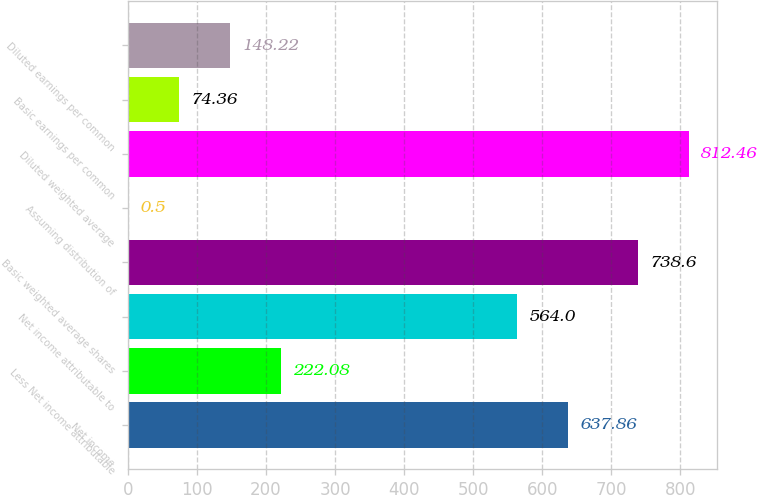Convert chart. <chart><loc_0><loc_0><loc_500><loc_500><bar_chart><fcel>Net income<fcel>Less Net income attributable<fcel>Net income attributable to<fcel>Basic weighted average shares<fcel>Assuming distribution of<fcel>Diluted weighted average<fcel>Basic earnings per common<fcel>Diluted earnings per common<nl><fcel>637.86<fcel>222.08<fcel>564<fcel>738.6<fcel>0.5<fcel>812.46<fcel>74.36<fcel>148.22<nl></chart> 